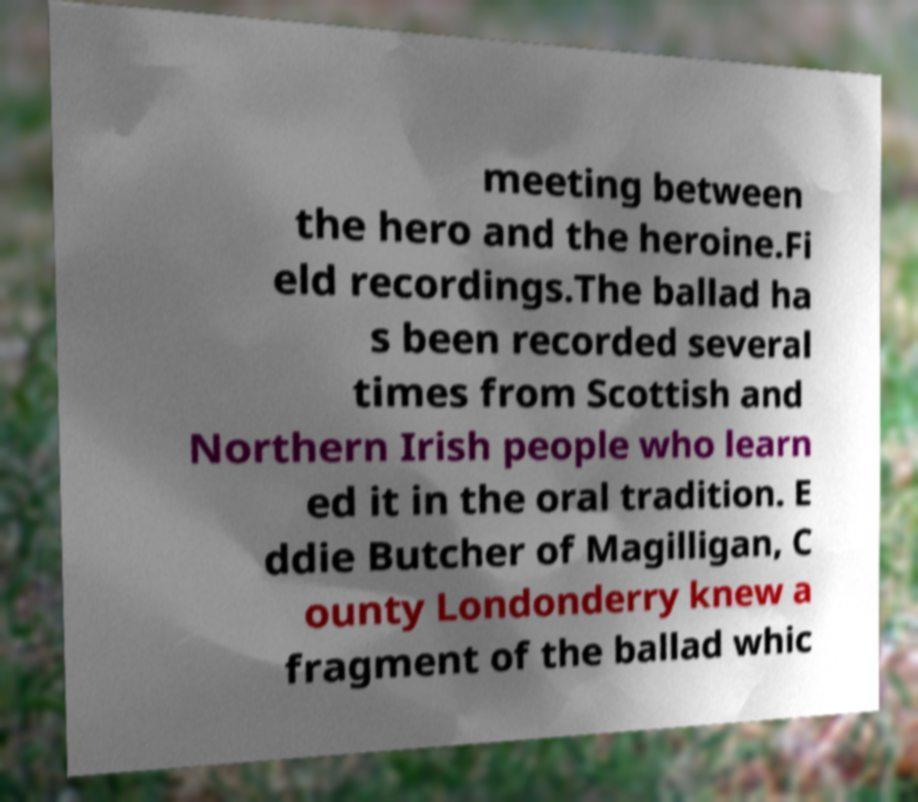For documentation purposes, I need the text within this image transcribed. Could you provide that? meeting between the hero and the heroine.Fi eld recordings.The ballad ha s been recorded several times from Scottish and Northern Irish people who learn ed it in the oral tradition. E ddie Butcher of Magilligan, C ounty Londonderry knew a fragment of the ballad whic 